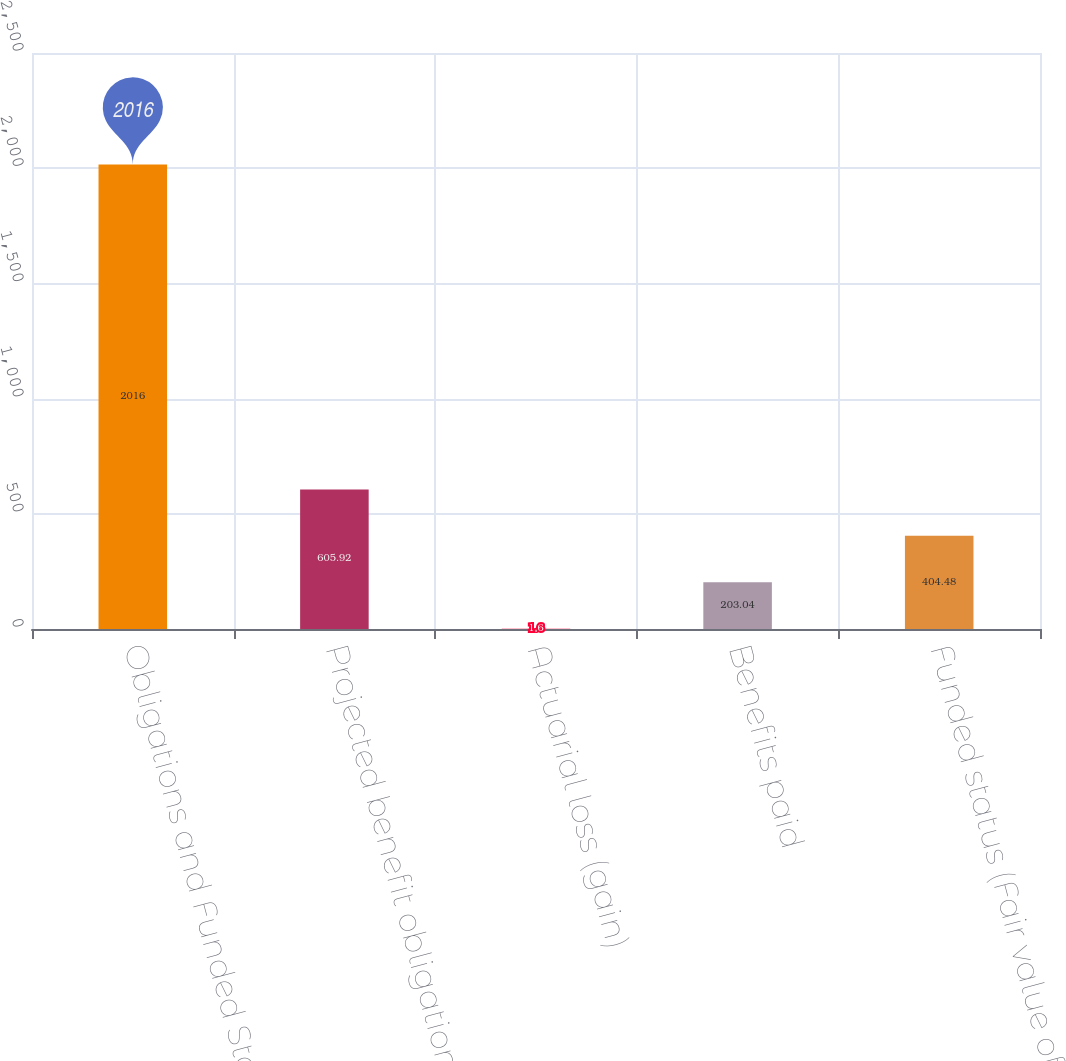Convert chart. <chart><loc_0><loc_0><loc_500><loc_500><bar_chart><fcel>Obligations and Funded Status<fcel>Projected benefit obligation<fcel>Actuarial loss (gain)<fcel>Benefits paid<fcel>Funded status (Fair value of<nl><fcel>2016<fcel>605.92<fcel>1.6<fcel>203.04<fcel>404.48<nl></chart> 